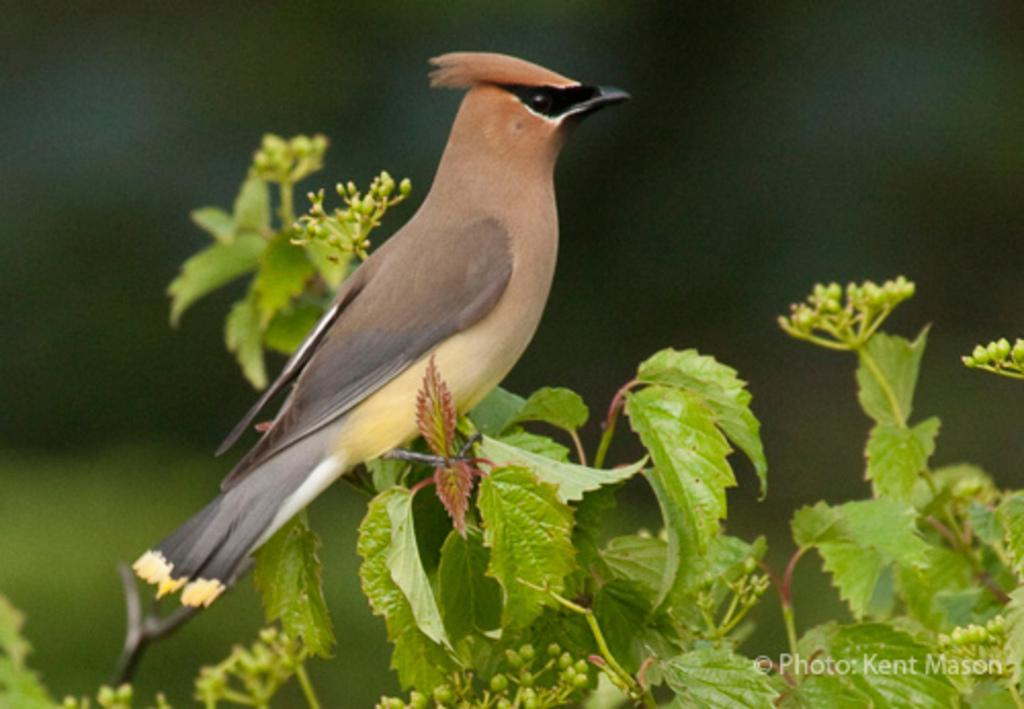What type of animal is in the image? There is a bird in the image. What is the bird standing on? The bird is standing on a plant. Can you describe the background of the image? The background of the image is blurry. What grade is the bird in the image? The image does not depict a bird in a school setting, so it is not possible to determine its grade. 